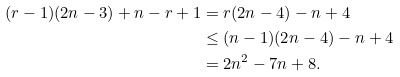Convert formula to latex. <formula><loc_0><loc_0><loc_500><loc_500>( r - 1 ) ( 2 n - 3 ) + n - r + 1 & = r ( 2 n - 4 ) - n + 4 \\ & \leq ( n - 1 ) ( 2 n - 4 ) - n + 4 \\ & = 2 n ^ { 2 } - 7 n + 8 .</formula> 